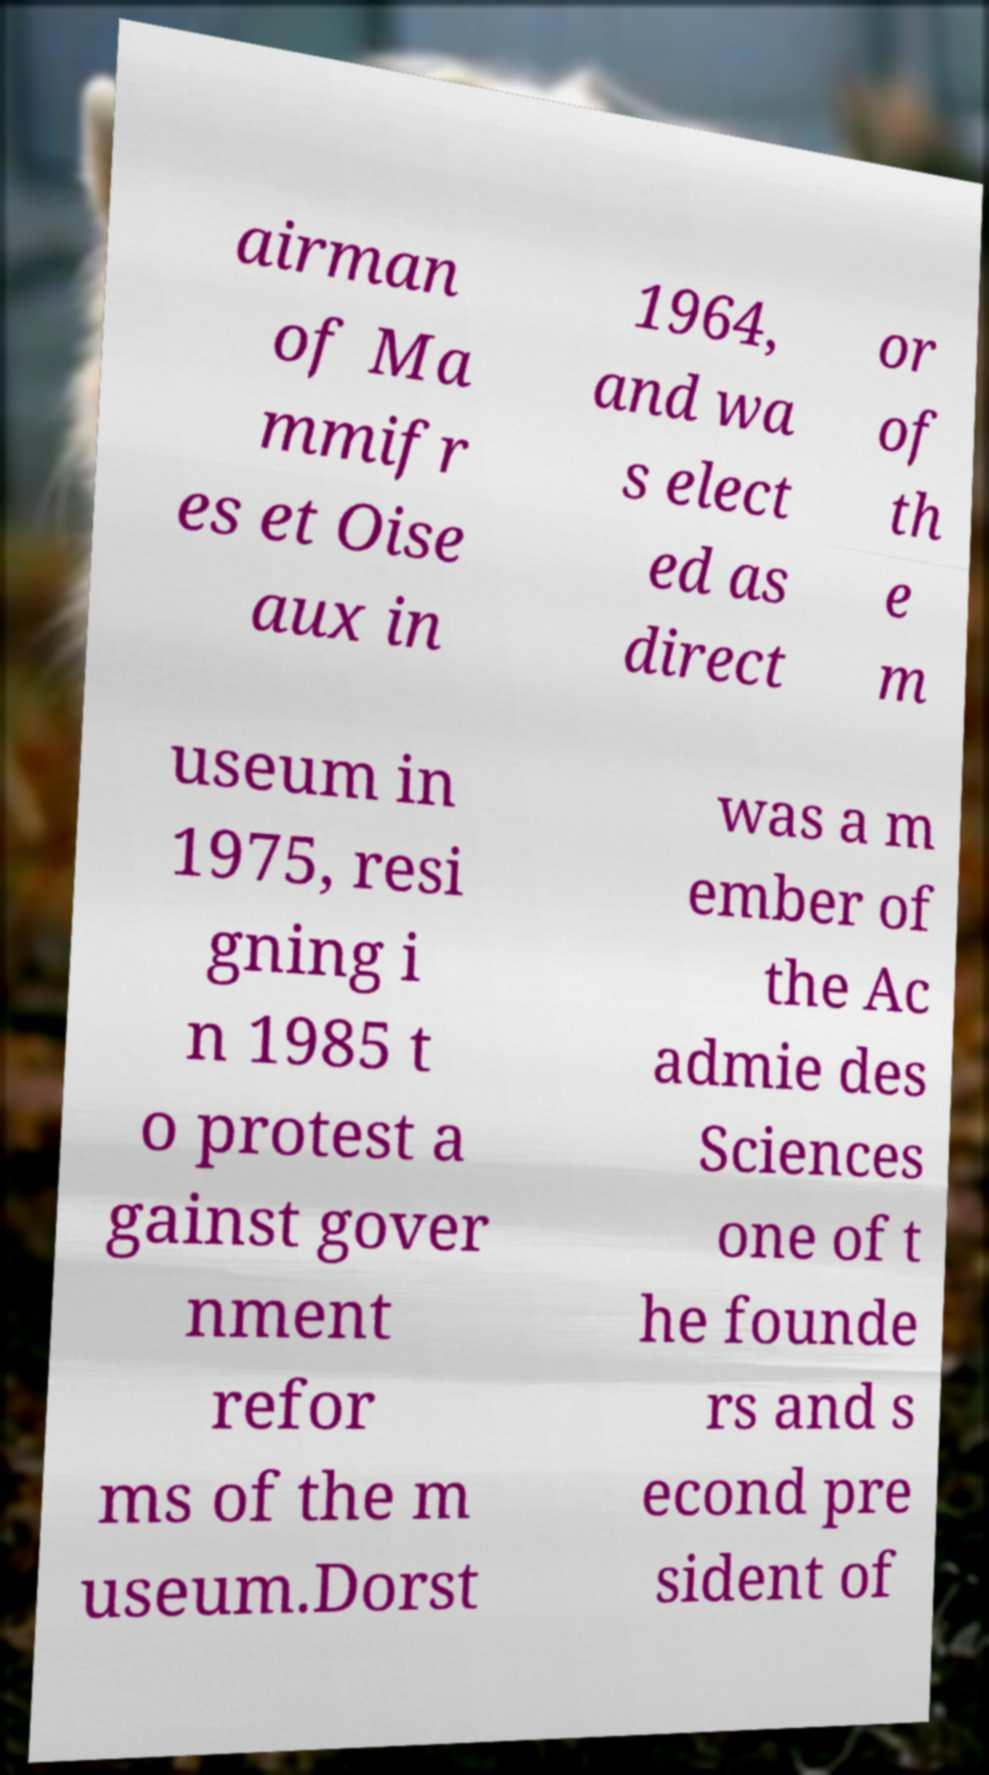Could you assist in decoding the text presented in this image and type it out clearly? airman of Ma mmifr es et Oise aux in 1964, and wa s elect ed as direct or of th e m useum in 1975, resi gning i n 1985 t o protest a gainst gover nment refor ms of the m useum.Dorst was a m ember of the Ac admie des Sciences one of t he founde rs and s econd pre sident of 